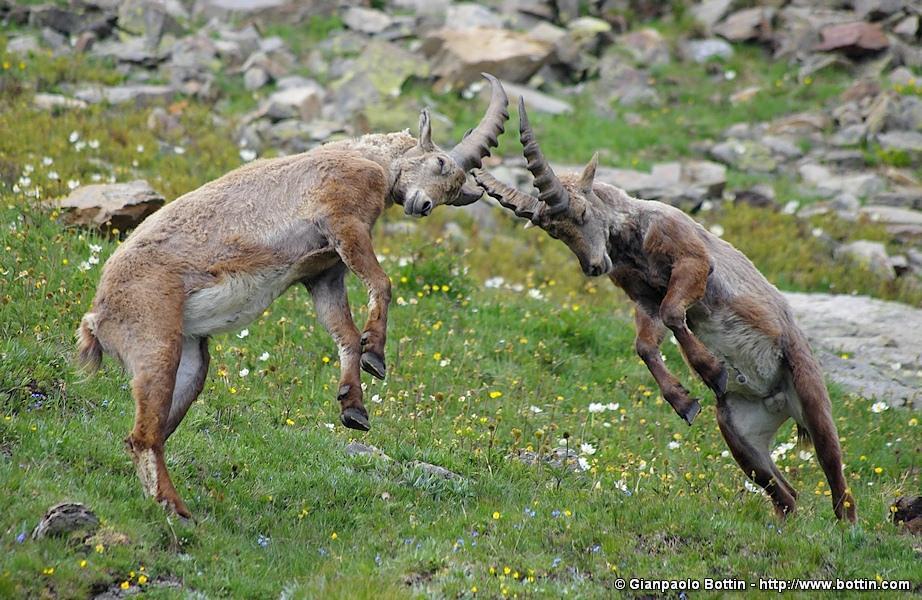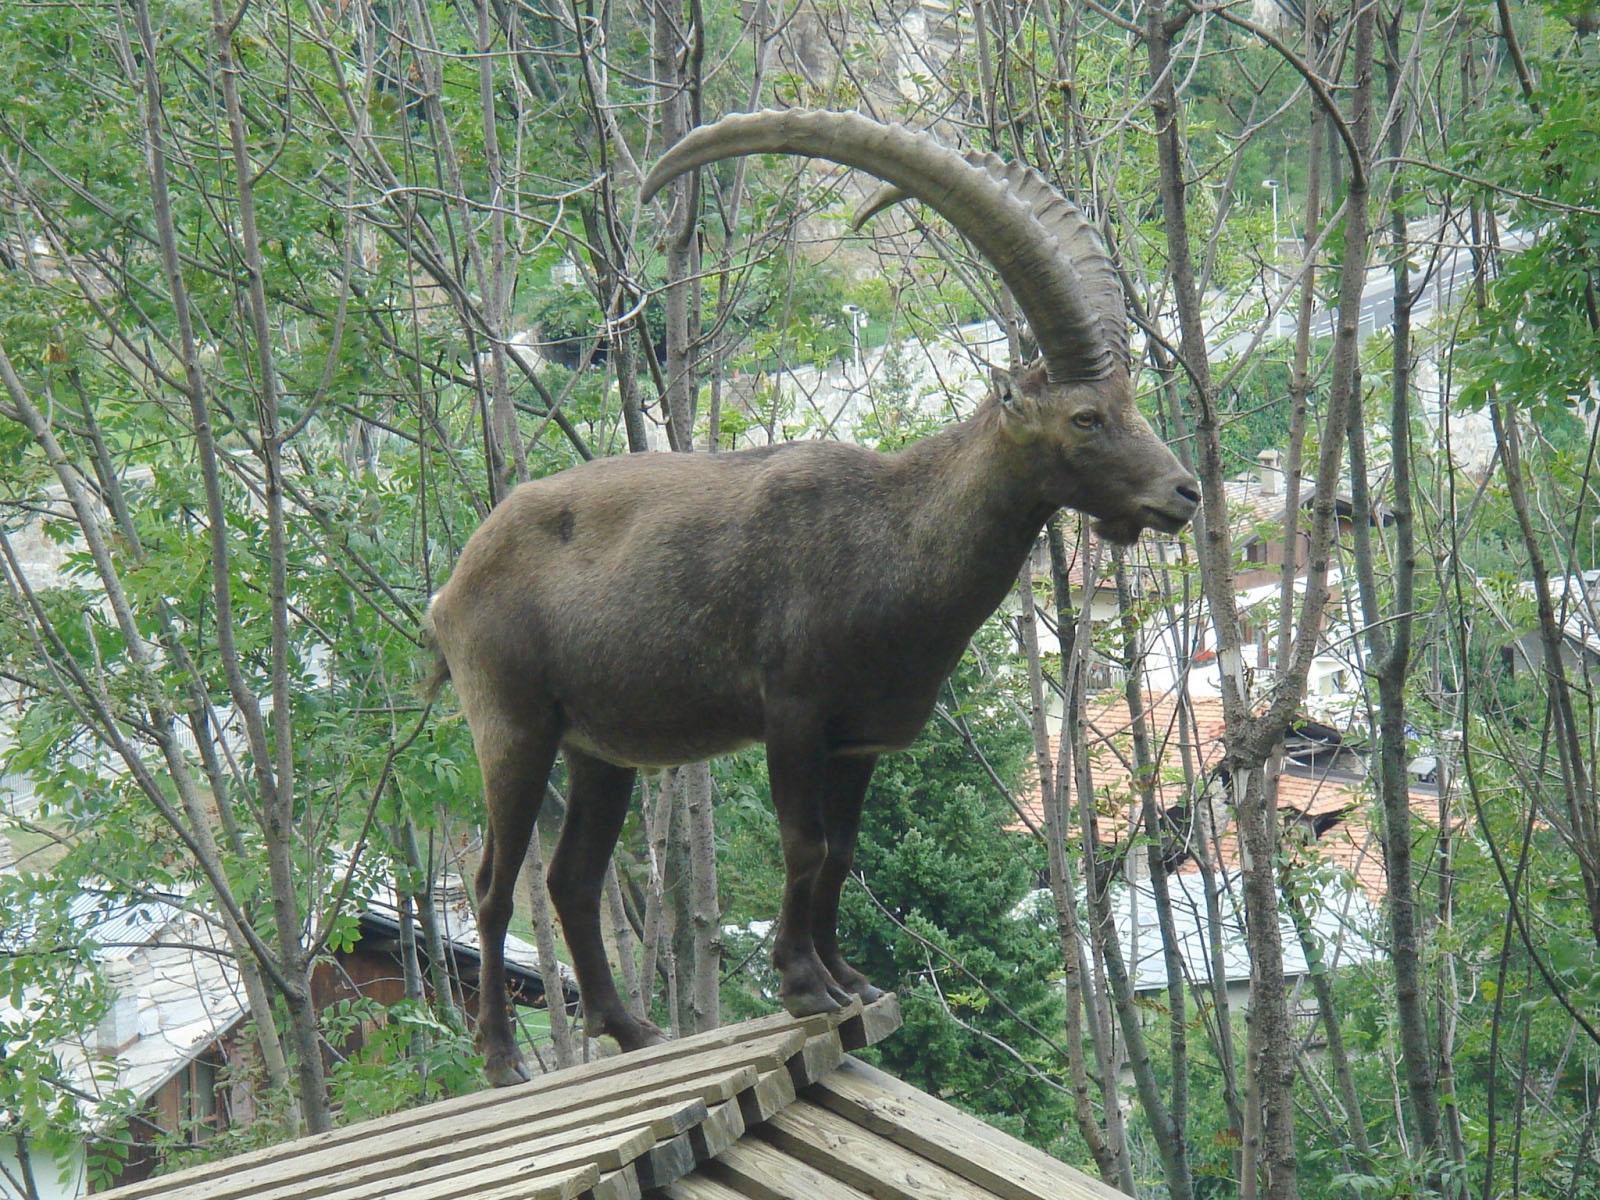The first image is the image on the left, the second image is the image on the right. For the images shown, is this caption "The left image shows two goats that are touching each other." true? Answer yes or no. Yes. 